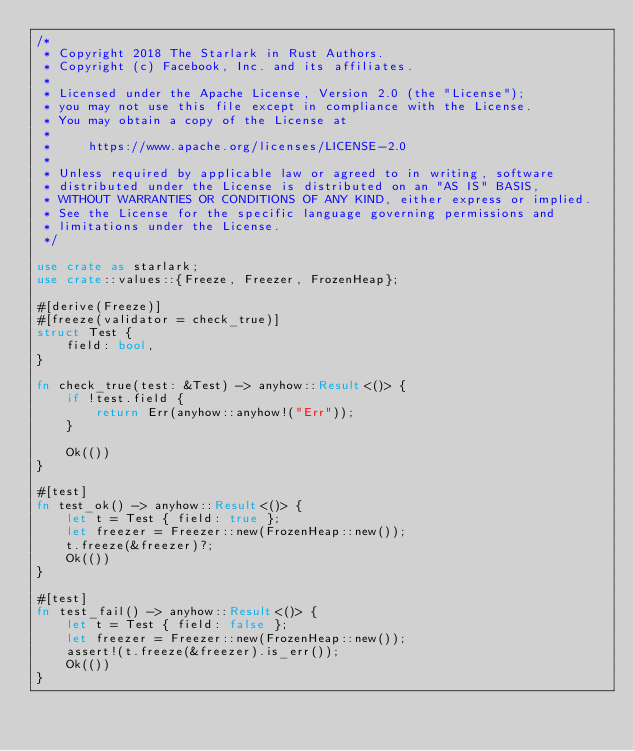Convert code to text. <code><loc_0><loc_0><loc_500><loc_500><_Rust_>/*
 * Copyright 2018 The Starlark in Rust Authors.
 * Copyright (c) Facebook, Inc. and its affiliates.
 *
 * Licensed under the Apache License, Version 2.0 (the "License");
 * you may not use this file except in compliance with the License.
 * You may obtain a copy of the License at
 *
 *     https://www.apache.org/licenses/LICENSE-2.0
 *
 * Unless required by applicable law or agreed to in writing, software
 * distributed under the License is distributed on an "AS IS" BASIS,
 * WITHOUT WARRANTIES OR CONDITIONS OF ANY KIND, either express or implied.
 * See the License for the specific language governing permissions and
 * limitations under the License.
 */

use crate as starlark;
use crate::values::{Freeze, Freezer, FrozenHeap};

#[derive(Freeze)]
#[freeze(validator = check_true)]
struct Test {
    field: bool,
}

fn check_true(test: &Test) -> anyhow::Result<()> {
    if !test.field {
        return Err(anyhow::anyhow!("Err"));
    }

    Ok(())
}

#[test]
fn test_ok() -> anyhow::Result<()> {
    let t = Test { field: true };
    let freezer = Freezer::new(FrozenHeap::new());
    t.freeze(&freezer)?;
    Ok(())
}

#[test]
fn test_fail() -> anyhow::Result<()> {
    let t = Test { field: false };
    let freezer = Freezer::new(FrozenHeap::new());
    assert!(t.freeze(&freezer).is_err());
    Ok(())
}
</code> 